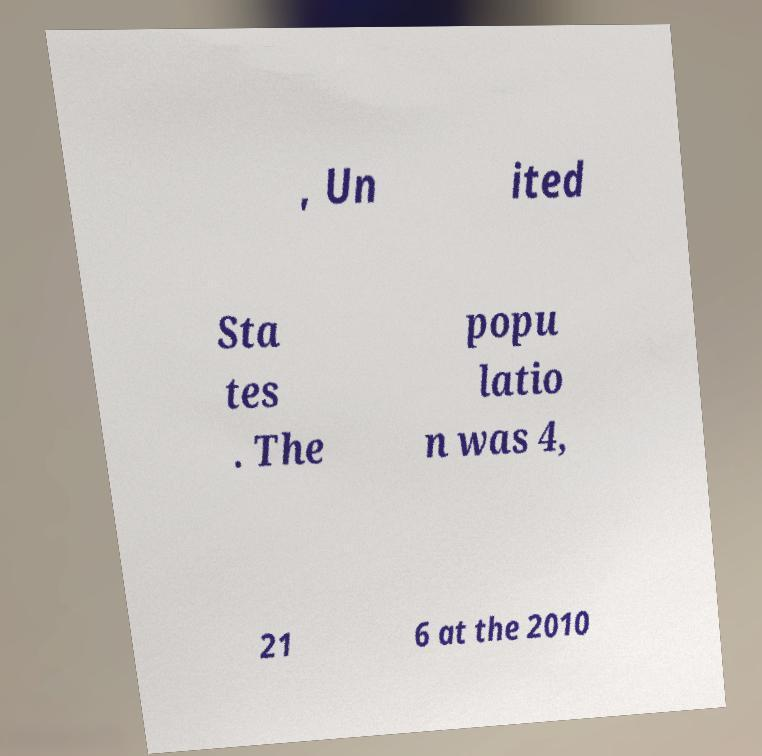Can you read and provide the text displayed in the image?This photo seems to have some interesting text. Can you extract and type it out for me? , Un ited Sta tes . The popu latio n was 4, 21 6 at the 2010 